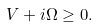<formula> <loc_0><loc_0><loc_500><loc_500>V + i \Omega \geq 0 .</formula> 